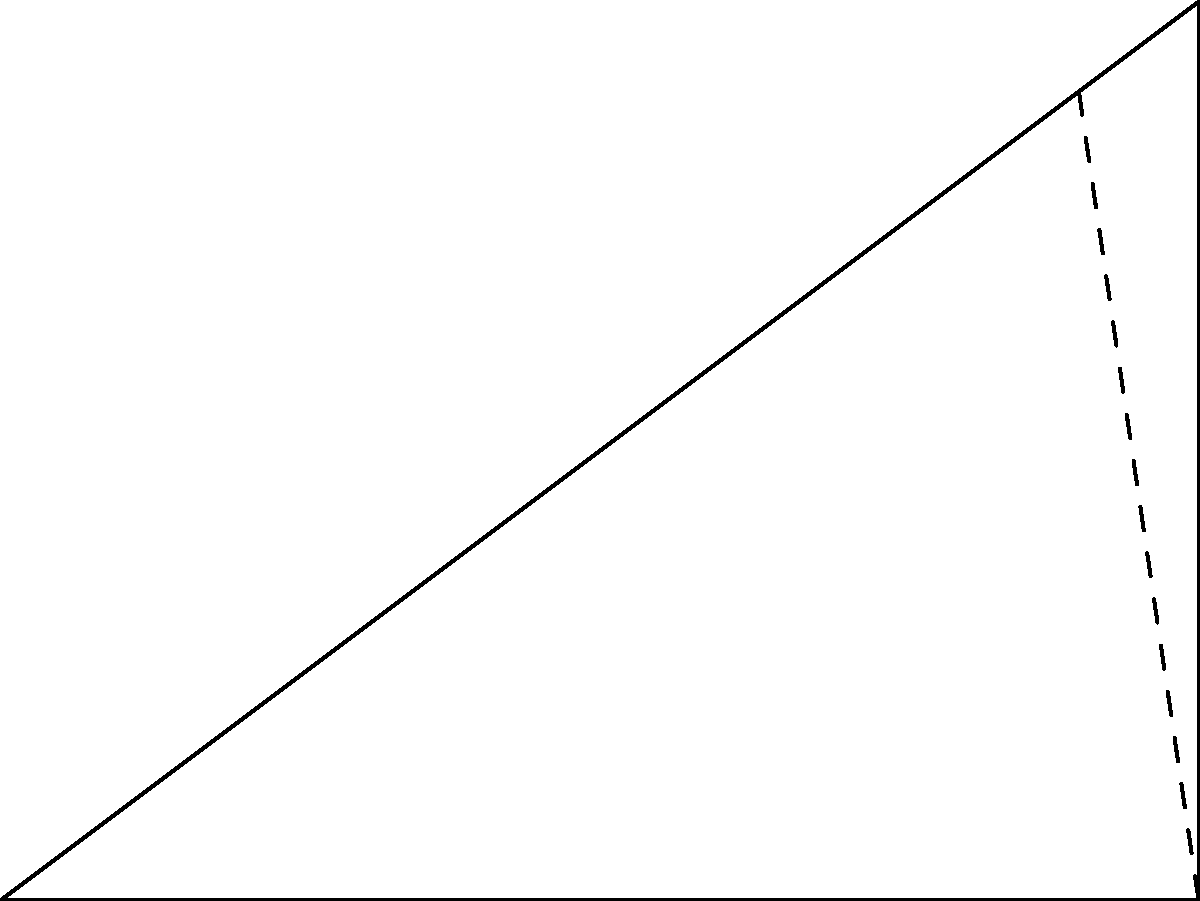A dermatologist is adjusting the laser focus for tattoo removal. The laser beam needs to penetrate 3 cm deep into the skin at a 30° angle from the surface. If the width of the treatment area is 4 cm, what is the length of the laser beam path from the point it enters the skin to the deepest point of the tattoo? Let's approach this step-by-step:

1) The diagram represents a right-angled triangle where:
   - The base (OA) is the width of the treatment area (4 cm)
   - The height (AB) is the depth of the tattoo (3 cm)
   - The hypotenuse (OB) is the laser beam path we need to find

2) We're given that the angle between the laser beam and the skin surface is 30°. This means that the angle BOA in our triangle is 60° (since the sum of angles in a triangle is 180°, and we have a right angle at A).

3) To find the length of OB, we can use the Pythagorean theorem:

   $OB^2 = OA^2 + AB^2$

4) Substituting the known values:

   $OB^2 = 4^2 + 3^2 = 16 + 9 = 25$

5) Taking the square root of both sides:

   $OB = \sqrt{25} = 5$

Therefore, the length of the laser beam path is 5 cm.

6) We can verify this using trigonometry:
   $\tan 60° = \frac{opposite}{adjacent} = \frac{3}{4} = \frac{\sqrt{3}}{2}$

   This is indeed the correct value for $\tan 60°$, confirming our calculation.
Answer: 5 cm 